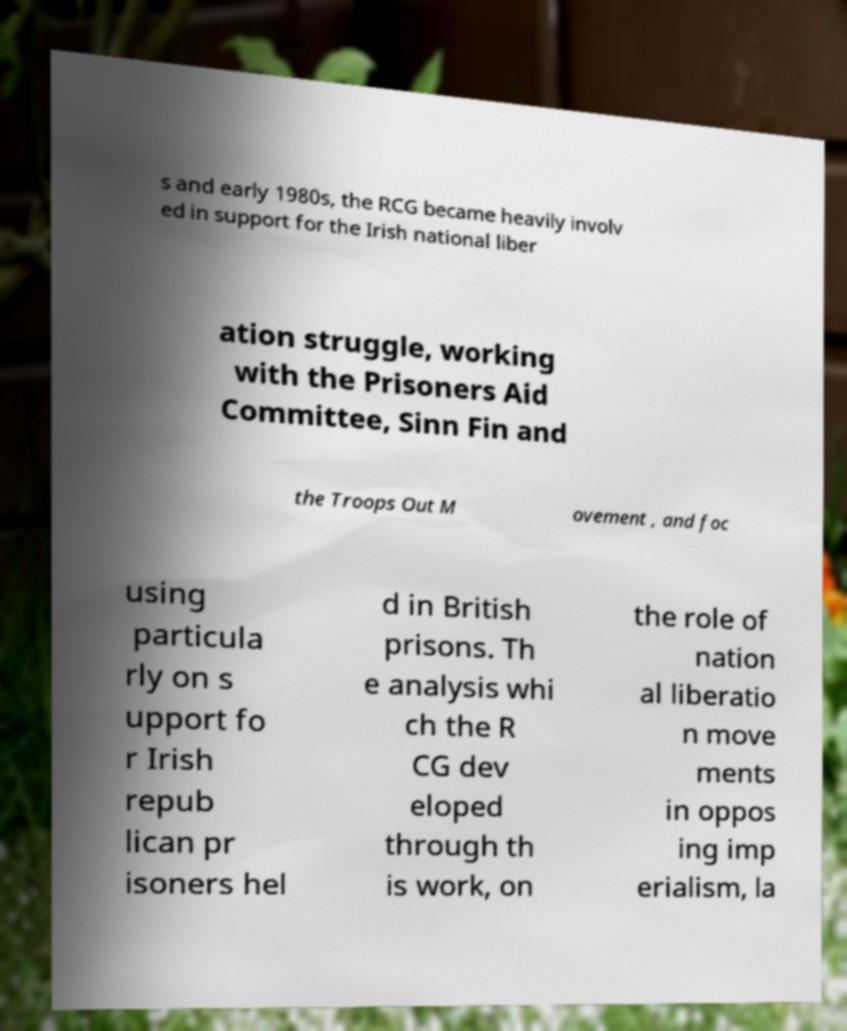Can you accurately transcribe the text from the provided image for me? s and early 1980s, the RCG became heavily involv ed in support for the Irish national liber ation struggle, working with the Prisoners Aid Committee, Sinn Fin and the Troops Out M ovement , and foc using particula rly on s upport fo r Irish repub lican pr isoners hel d in British prisons. Th e analysis whi ch the R CG dev eloped through th is work, on the role of nation al liberatio n move ments in oppos ing imp erialism, la 